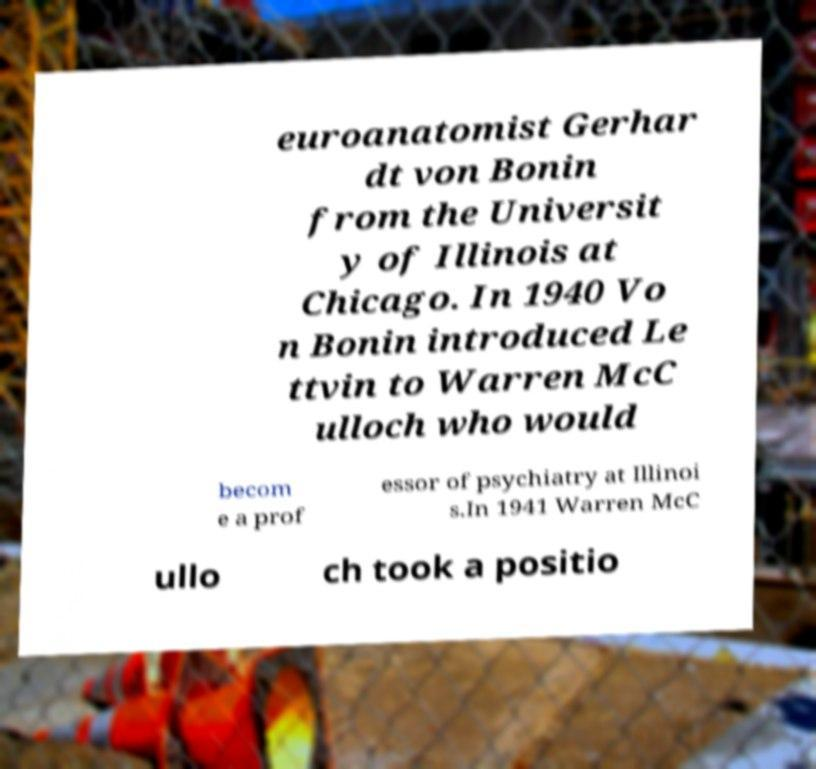For documentation purposes, I need the text within this image transcribed. Could you provide that? euroanatomist Gerhar dt von Bonin from the Universit y of Illinois at Chicago. In 1940 Vo n Bonin introduced Le ttvin to Warren McC ulloch who would becom e a prof essor of psychiatry at Illinoi s.In 1941 Warren McC ullo ch took a positio 